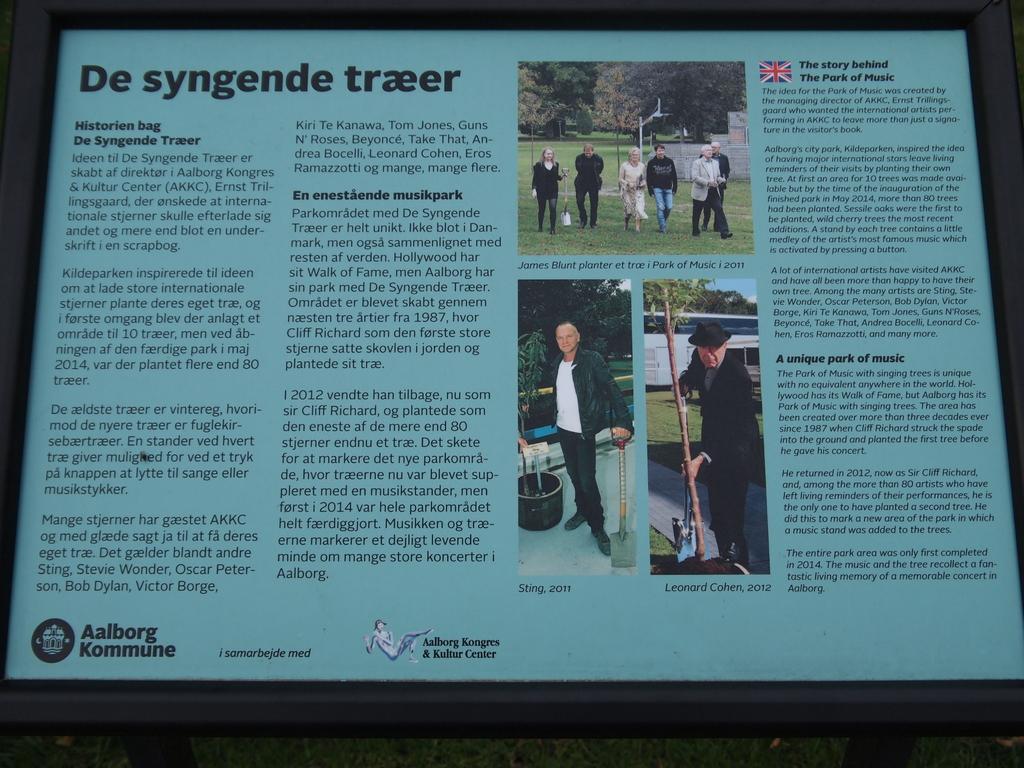What kind of park is this information about?
Give a very brief answer. Music. What is the words at the bottom left?
Give a very brief answer. Aalborg kommune. 